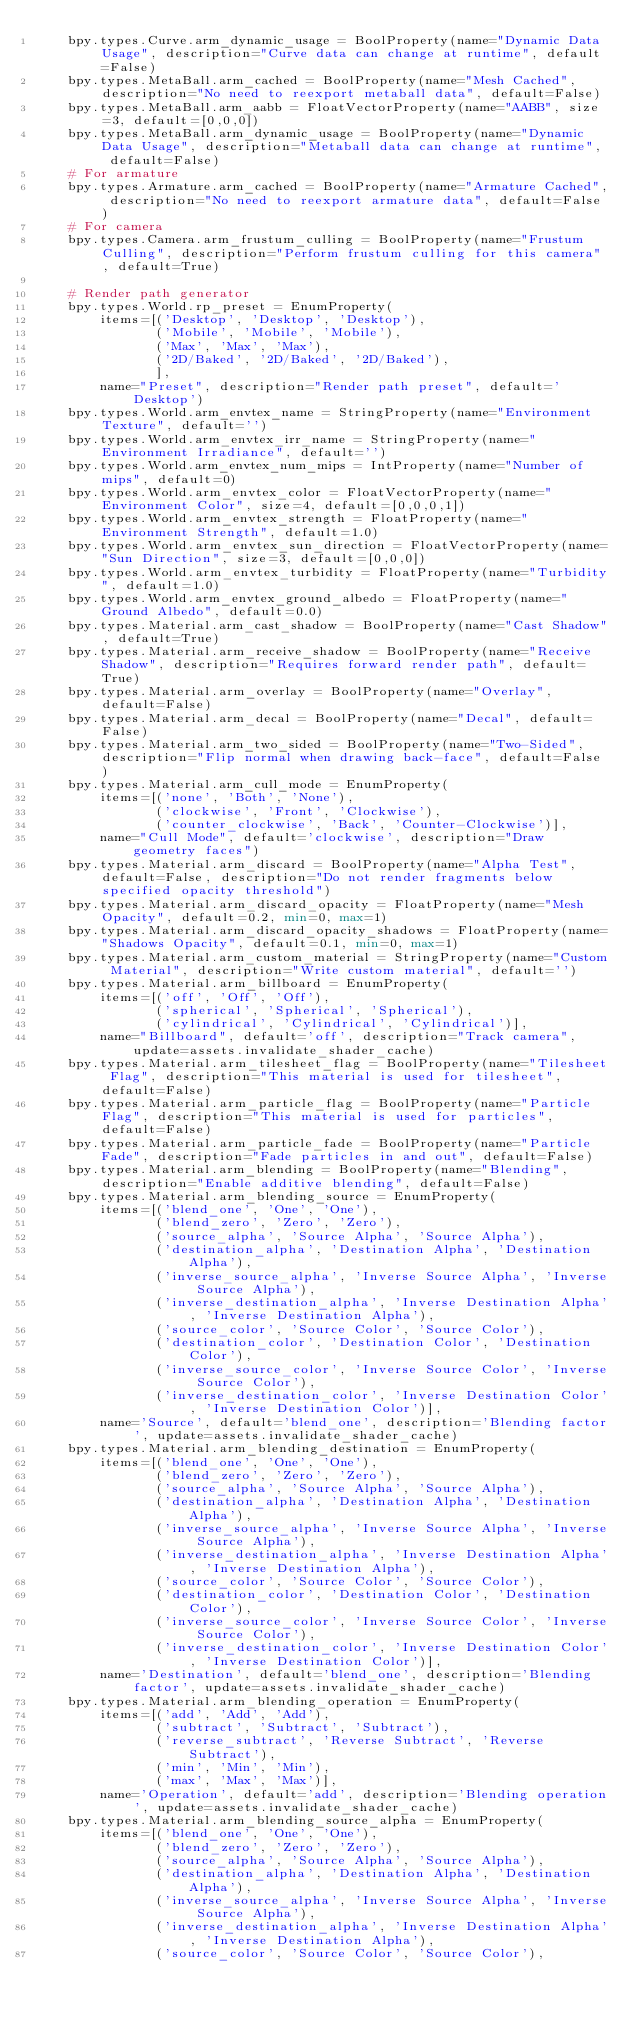Convert code to text. <code><loc_0><loc_0><loc_500><loc_500><_Python_>    bpy.types.Curve.arm_dynamic_usage = BoolProperty(name="Dynamic Data Usage", description="Curve data can change at runtime", default=False)
    bpy.types.MetaBall.arm_cached = BoolProperty(name="Mesh Cached", description="No need to reexport metaball data", default=False)
    bpy.types.MetaBall.arm_aabb = FloatVectorProperty(name="AABB", size=3, default=[0,0,0])
    bpy.types.MetaBall.arm_dynamic_usage = BoolProperty(name="Dynamic Data Usage", description="Metaball data can change at runtime", default=False)
    # For armature
    bpy.types.Armature.arm_cached = BoolProperty(name="Armature Cached", description="No need to reexport armature data", default=False)
    # For camera
    bpy.types.Camera.arm_frustum_culling = BoolProperty(name="Frustum Culling", description="Perform frustum culling for this camera", default=True)

    # Render path generator
    bpy.types.World.rp_preset = EnumProperty(
        items=[('Desktop', 'Desktop', 'Desktop'),
               ('Mobile', 'Mobile', 'Mobile'),
               ('Max', 'Max', 'Max'),
               ('2D/Baked', '2D/Baked', '2D/Baked'),
               ],
        name="Preset", description="Render path preset", default='Desktop')
    bpy.types.World.arm_envtex_name = StringProperty(name="Environment Texture", default='')
    bpy.types.World.arm_envtex_irr_name = StringProperty(name="Environment Irradiance", default='')
    bpy.types.World.arm_envtex_num_mips = IntProperty(name="Number of mips", default=0)
    bpy.types.World.arm_envtex_color = FloatVectorProperty(name="Environment Color", size=4, default=[0,0,0,1])
    bpy.types.World.arm_envtex_strength = FloatProperty(name="Environment Strength", default=1.0)
    bpy.types.World.arm_envtex_sun_direction = FloatVectorProperty(name="Sun Direction", size=3, default=[0,0,0])
    bpy.types.World.arm_envtex_turbidity = FloatProperty(name="Turbidity", default=1.0)
    bpy.types.World.arm_envtex_ground_albedo = FloatProperty(name="Ground Albedo", default=0.0)
    bpy.types.Material.arm_cast_shadow = BoolProperty(name="Cast Shadow", default=True)
    bpy.types.Material.arm_receive_shadow = BoolProperty(name="Receive Shadow", description="Requires forward render path", default=True)
    bpy.types.Material.arm_overlay = BoolProperty(name="Overlay", default=False)
    bpy.types.Material.arm_decal = BoolProperty(name="Decal", default=False)
    bpy.types.Material.arm_two_sided = BoolProperty(name="Two-Sided", description="Flip normal when drawing back-face", default=False)
    bpy.types.Material.arm_cull_mode = EnumProperty(
        items=[('none', 'Both', 'None'),
               ('clockwise', 'Front', 'Clockwise'),
               ('counter_clockwise', 'Back', 'Counter-Clockwise')],
        name="Cull Mode", default='clockwise', description="Draw geometry faces")
    bpy.types.Material.arm_discard = BoolProperty(name="Alpha Test", default=False, description="Do not render fragments below specified opacity threshold")
    bpy.types.Material.arm_discard_opacity = FloatProperty(name="Mesh Opacity", default=0.2, min=0, max=1)
    bpy.types.Material.arm_discard_opacity_shadows = FloatProperty(name="Shadows Opacity", default=0.1, min=0, max=1)
    bpy.types.Material.arm_custom_material = StringProperty(name="Custom Material", description="Write custom material", default='')
    bpy.types.Material.arm_billboard = EnumProperty(
        items=[('off', 'Off', 'Off'),
               ('spherical', 'Spherical', 'Spherical'),
               ('cylindrical', 'Cylindrical', 'Cylindrical')],
        name="Billboard", default='off', description="Track camera", update=assets.invalidate_shader_cache)
    bpy.types.Material.arm_tilesheet_flag = BoolProperty(name="Tilesheet Flag", description="This material is used for tilesheet", default=False)
    bpy.types.Material.arm_particle_flag = BoolProperty(name="Particle Flag", description="This material is used for particles", default=False)
    bpy.types.Material.arm_particle_fade = BoolProperty(name="Particle Fade", description="Fade particles in and out", default=False)
    bpy.types.Material.arm_blending = BoolProperty(name="Blending", description="Enable additive blending", default=False)
    bpy.types.Material.arm_blending_source = EnumProperty(
        items=[('blend_one', 'One', 'One'),
               ('blend_zero', 'Zero', 'Zero'),
               ('source_alpha', 'Source Alpha', 'Source Alpha'),
               ('destination_alpha', 'Destination Alpha', 'Destination Alpha'),
               ('inverse_source_alpha', 'Inverse Source Alpha', 'Inverse Source Alpha'),
               ('inverse_destination_alpha', 'Inverse Destination Alpha', 'Inverse Destination Alpha'),
               ('source_color', 'Source Color', 'Source Color'),
               ('destination_color', 'Destination Color', 'Destination Color'),
               ('inverse_source_color', 'Inverse Source Color', 'Inverse Source Color'),
               ('inverse_destination_color', 'Inverse Destination Color', 'Inverse Destination Color')],
        name='Source', default='blend_one', description='Blending factor', update=assets.invalidate_shader_cache)
    bpy.types.Material.arm_blending_destination = EnumProperty(
        items=[('blend_one', 'One', 'One'),
               ('blend_zero', 'Zero', 'Zero'),
               ('source_alpha', 'Source Alpha', 'Source Alpha'),
               ('destination_alpha', 'Destination Alpha', 'Destination Alpha'),
               ('inverse_source_alpha', 'Inverse Source Alpha', 'Inverse Source Alpha'),
               ('inverse_destination_alpha', 'Inverse Destination Alpha', 'Inverse Destination Alpha'),
               ('source_color', 'Source Color', 'Source Color'),
               ('destination_color', 'Destination Color', 'Destination Color'),
               ('inverse_source_color', 'Inverse Source Color', 'Inverse Source Color'),
               ('inverse_destination_color', 'Inverse Destination Color', 'Inverse Destination Color')],
        name='Destination', default='blend_one', description='Blending factor', update=assets.invalidate_shader_cache)
    bpy.types.Material.arm_blending_operation = EnumProperty(
        items=[('add', 'Add', 'Add'),
               ('subtract', 'Subtract', 'Subtract'),
               ('reverse_subtract', 'Reverse Subtract', 'Reverse Subtract'),
               ('min', 'Min', 'Min'),
               ('max', 'Max', 'Max')],
        name='Operation', default='add', description='Blending operation', update=assets.invalidate_shader_cache)
    bpy.types.Material.arm_blending_source_alpha = EnumProperty(
        items=[('blend_one', 'One', 'One'),
               ('blend_zero', 'Zero', 'Zero'),
               ('source_alpha', 'Source Alpha', 'Source Alpha'),
               ('destination_alpha', 'Destination Alpha', 'Destination Alpha'),
               ('inverse_source_alpha', 'Inverse Source Alpha', 'Inverse Source Alpha'),
               ('inverse_destination_alpha', 'Inverse Destination Alpha', 'Inverse Destination Alpha'),
               ('source_color', 'Source Color', 'Source Color'),</code> 